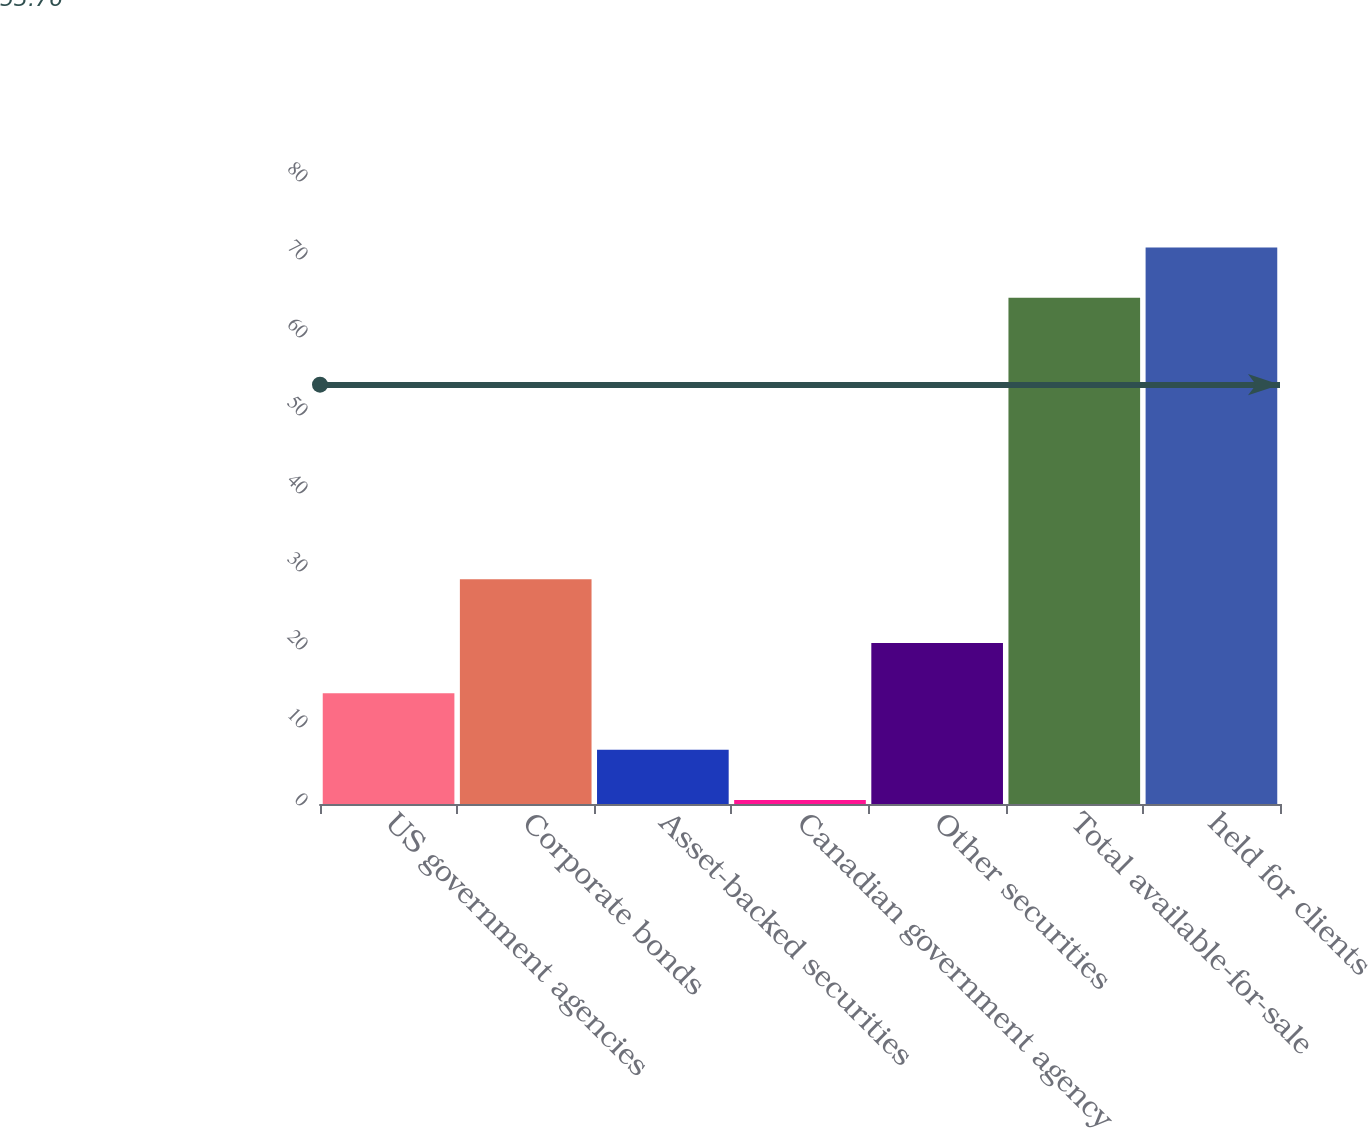Convert chart. <chart><loc_0><loc_0><loc_500><loc_500><bar_chart><fcel>US government agencies<fcel>Corporate bonds<fcel>Asset-backed securities<fcel>Canadian government agency<fcel>Other securities<fcel>Total available-for-sale<fcel>held for clients<nl><fcel>14.2<fcel>28.8<fcel>6.94<fcel>0.5<fcel>20.64<fcel>64.9<fcel>71.34<nl></chart> 